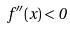Convert formula to latex. <formula><loc_0><loc_0><loc_500><loc_500>f ^ { \prime \prime } ( x ) < 0</formula> 